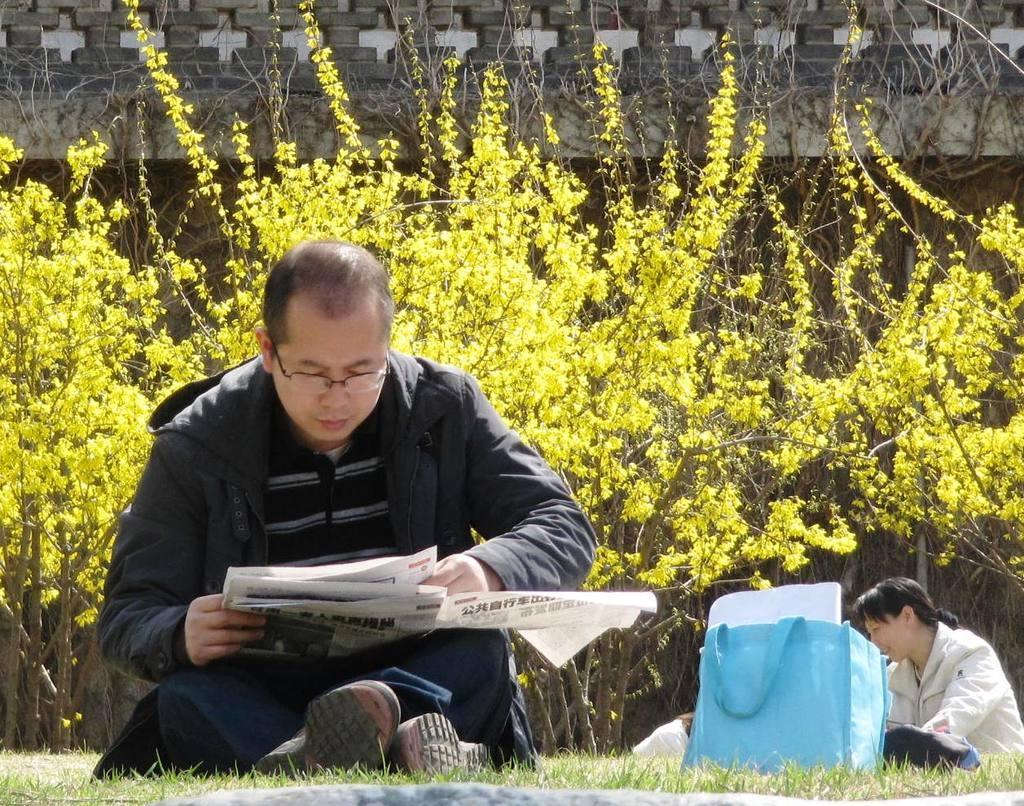In one or two sentences, can you explain what this image depicts? In this image, we can see a man sitting and reading newspaper. On the right, there is a lady sitting and we can see a bag. In the background, there are trees and there is a wall. 